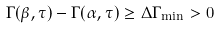Convert formula to latex. <formula><loc_0><loc_0><loc_500><loc_500>\Gamma ( \beta , \tau ) - \Gamma ( \alpha , \tau ) \geq \Delta \Gamma _ { \min } > 0</formula> 